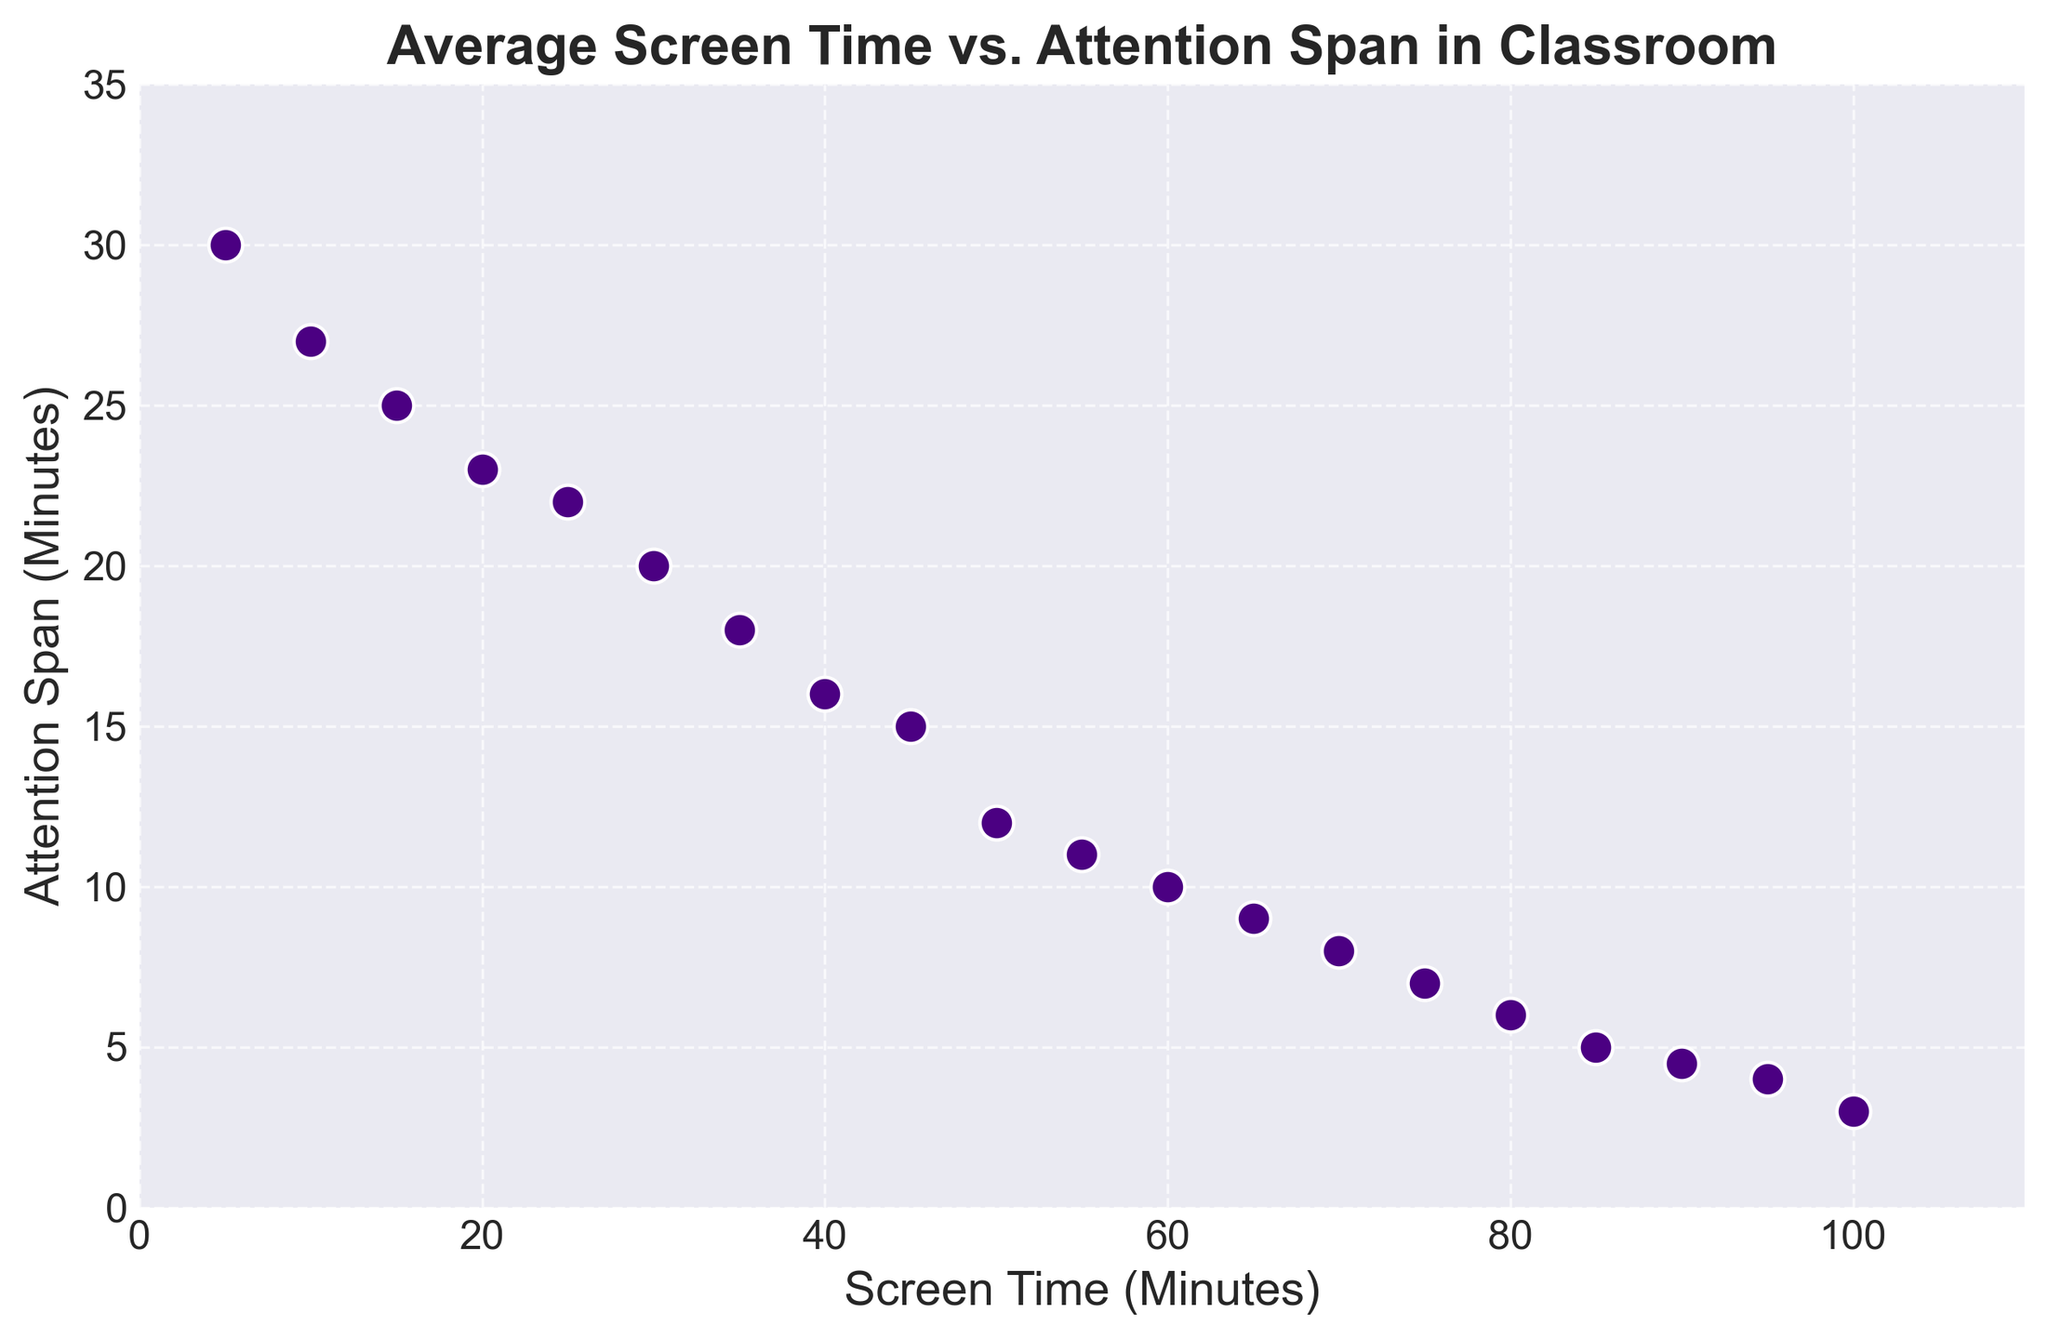What is the relationship between screen time and attention span in the context of the points plotted on the graph? The scatter plot shows a negative correlation between screen time and attention span, indicating that as screen time increases, attention span decreases. This is evident in the trend seen on the plot where points representing higher screen times correspond to lower attention spans.
Answer: Negative correlation What is the attention span for a screen time of 50 minutes? To find the attention span for a screen time of 50 minutes, locate the point on the scatter plot where the x-axis value is 50. The corresponding y-axis value at this point gives the attention span.
Answer: 12 minutes Which student has the highest attention span, and what is their screen time? To find the student with the highest attention span, look for the highest point along the y-axis. The y-axis value represents the highest attention span and the x-axis value at that point represents their screen time. The highest attention span is 30 minutes, which corresponds to a screen time of 5 minutes.
Answer: 30 minutes, 5 minutes Compare the attention spans between students with screen times of 60 minutes and 90 minutes. Locate the points for screen times of 60 minutes and 90 minutes on the x-axis. Compare the corresponding y-axis values. For 60 minutes of screen time, the attention span is 10 minutes, and for 90 minutes of screen time, the attention span is 4.5 minutes.
Answer: 10 minutes vs 4.5 minutes What is the average attention span for students with less than 40 minutes of screen time? Identify the points with screen times less than 40 minutes: 30, 25, 20, 35, 15, and 10 minutes. Their attention spans are 20, 22, 23, 18, 25, and 27 minutes respectively. Calculate the average: (20 + 22 + 23 + 18 + 25 + 27) / 6 = 135 / 6 = 22.5 minutes.
Answer: 22.5 minutes Compare the attention spans for screen times of 30 minutes and 65 minutes. Which is higher? Locate the points for screen times of 30 minutes and 65 minutes on the x-axis and check their corresponding y-axis values (attention spans). The attention span for 30 minutes of screen time is 20 minutes, and for 65 minutes, it is 9 minutes. 20 minutes is higher than 9 minutes.
Answer: 30 minutes (20 minutes) What is the difference in attention spans between the highest and lowest screen times? Identify the points with the highest screen time (100 minutes) and the lowest screen time (5 minutes). Their attention spans are 3 minutes and 30 minutes respectively. The difference is calculated as 30 - 3 = 27 minutes.
Answer: 27 minutes What general pattern can you observe as screen time increases? Observing the plot as a whole, it can be seen that as screen time increases (moving to the right along the x-axis), the attention span generally decreases (moving down the y-axis), indicating a trend where more screen time is associated with shorter attention spans.
Answer: Decreasing attention span Calculate the average attention span for all students in the plot data. Sum the attention spans provided: 20 + 15 + 10 + 22 + 12 + 16 + 18 + 8 + 11 + 9 + 23 + 7 + 6 + 25 + 5 + 27 + 4 + 30 + 4.5 + 3 = 276.5. Divide by the number of data points, which is 20: 276.5 / 20 = 13.825 minutes.
Answer: 13.825 minutes 